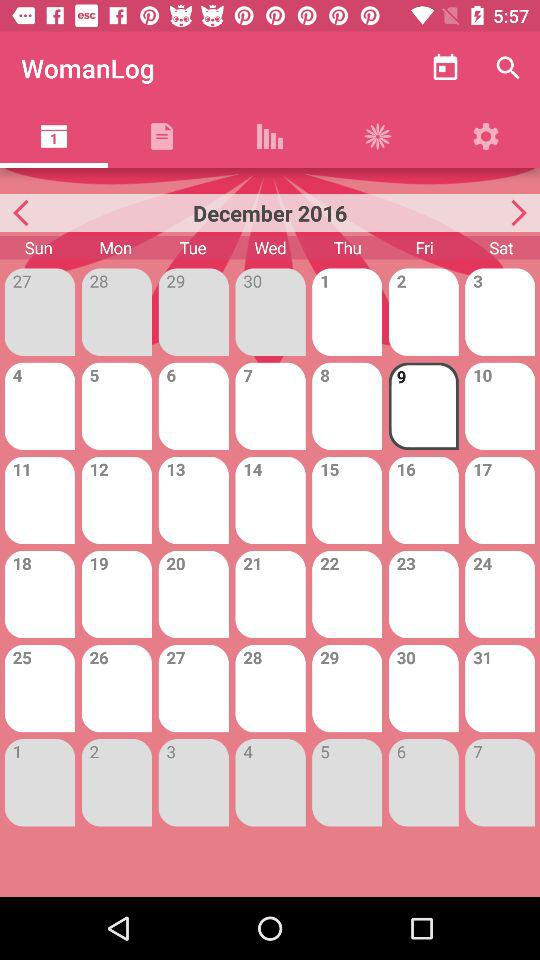What is the day on the selected date? The day is Friday. 